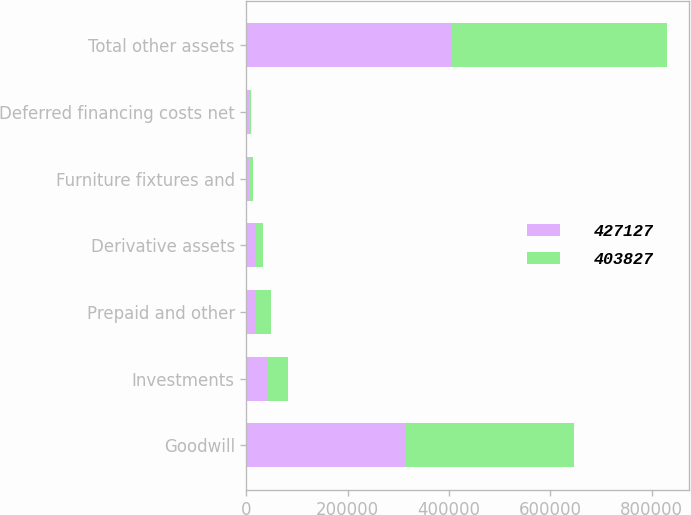Convert chart. <chart><loc_0><loc_0><loc_500><loc_500><stacked_bar_chart><ecel><fcel>Goodwill<fcel>Investments<fcel>Prepaid and other<fcel>Derivative assets<fcel>Furniture fixtures and<fcel>Deferred financing costs net<fcel>Total other assets<nl><fcel>427127<fcel>314143<fcel>41287<fcel>17937<fcel>17482<fcel>6127<fcel>6851<fcel>403827<nl><fcel>403827<fcel>331884<fcel>41636<fcel>30332<fcel>14515<fcel>6123<fcel>2637<fcel>427127<nl></chart> 